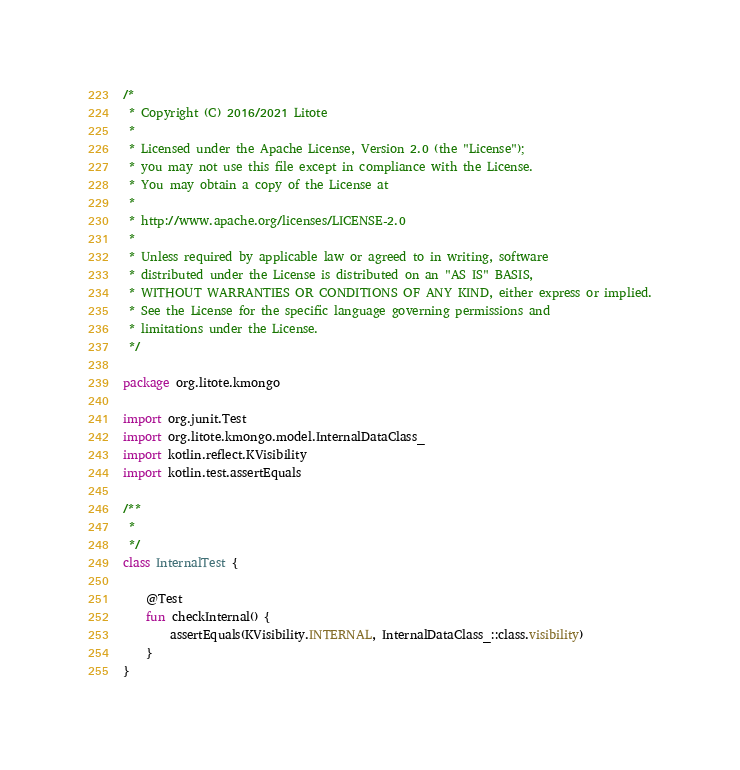Convert code to text. <code><loc_0><loc_0><loc_500><loc_500><_Kotlin_>/*
 * Copyright (C) 2016/2021 Litote
 *
 * Licensed under the Apache License, Version 2.0 (the "License");
 * you may not use this file except in compliance with the License.
 * You may obtain a copy of the License at
 *
 * http://www.apache.org/licenses/LICENSE-2.0
 *
 * Unless required by applicable law or agreed to in writing, software
 * distributed under the License is distributed on an "AS IS" BASIS,
 * WITHOUT WARRANTIES OR CONDITIONS OF ANY KIND, either express or implied.
 * See the License for the specific language governing permissions and
 * limitations under the License.
 */

package org.litote.kmongo

import org.junit.Test
import org.litote.kmongo.model.InternalDataClass_
import kotlin.reflect.KVisibility
import kotlin.test.assertEquals

/**
 *
 */
class InternalTest {

    @Test
    fun checkInternal() {
        assertEquals(KVisibility.INTERNAL, InternalDataClass_::class.visibility)
    }
}</code> 